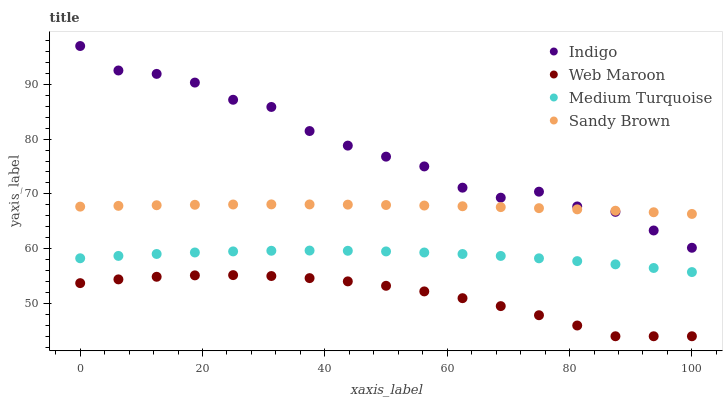Does Web Maroon have the minimum area under the curve?
Answer yes or no. Yes. Does Indigo have the maximum area under the curve?
Answer yes or no. Yes. Does Sandy Brown have the minimum area under the curve?
Answer yes or no. No. Does Sandy Brown have the maximum area under the curve?
Answer yes or no. No. Is Sandy Brown the smoothest?
Answer yes or no. Yes. Is Indigo the roughest?
Answer yes or no. Yes. Is Indigo the smoothest?
Answer yes or no. No. Is Sandy Brown the roughest?
Answer yes or no. No. Does Web Maroon have the lowest value?
Answer yes or no. Yes. Does Indigo have the lowest value?
Answer yes or no. No. Does Indigo have the highest value?
Answer yes or no. Yes. Does Sandy Brown have the highest value?
Answer yes or no. No. Is Web Maroon less than Indigo?
Answer yes or no. Yes. Is Indigo greater than Medium Turquoise?
Answer yes or no. Yes. Does Sandy Brown intersect Indigo?
Answer yes or no. Yes. Is Sandy Brown less than Indigo?
Answer yes or no. No. Is Sandy Brown greater than Indigo?
Answer yes or no. No. Does Web Maroon intersect Indigo?
Answer yes or no. No. 